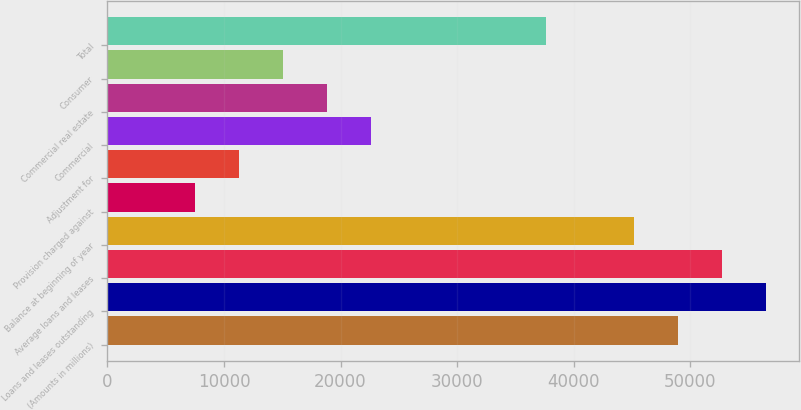Convert chart. <chart><loc_0><loc_0><loc_500><loc_500><bar_chart><fcel>(Amounts in millions)<fcel>Loans and leases outstanding<fcel>Average loans and leases<fcel>Balance at beginning of year<fcel>Provision charged against<fcel>Adjustment for<fcel>Commercial<fcel>Commercial real estate<fcel>Consumer<fcel>Total<nl><fcel>48964.4<fcel>56497.3<fcel>52730.9<fcel>45197.9<fcel>7533.34<fcel>11299.8<fcel>22599.2<fcel>18832.7<fcel>15066.3<fcel>37665<nl></chart> 